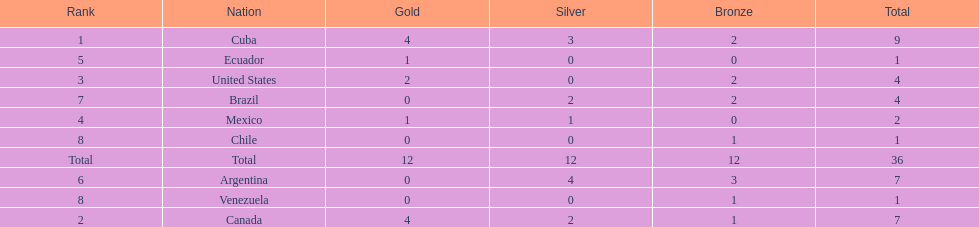What is the total number of nations that did not win gold? 4. 